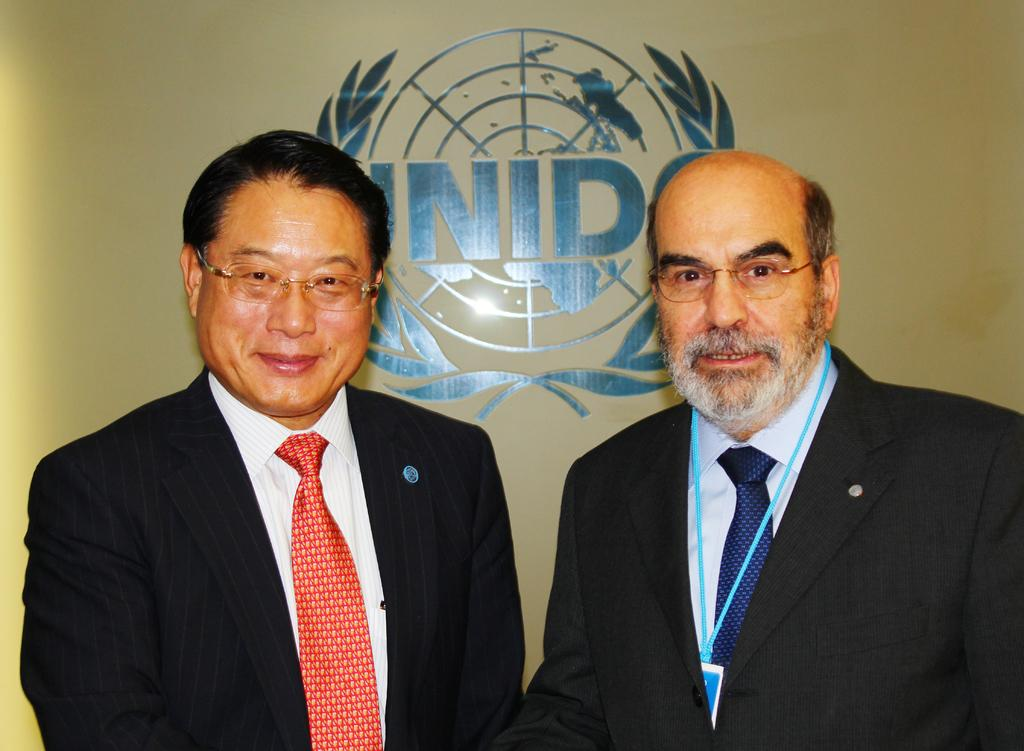How many people are in the image? There are two men in the image. What are the men wearing on their faces? Both men are wearing spectacles. Can you describe any distinguishing features of the men? The right side man is wearing a tag. What type of cow can be seen grazing in the background of the image? There is no cow present in the image. Can you tell me how many dimes are scattered on the ground in the image? There are no dimes visible in the image. 